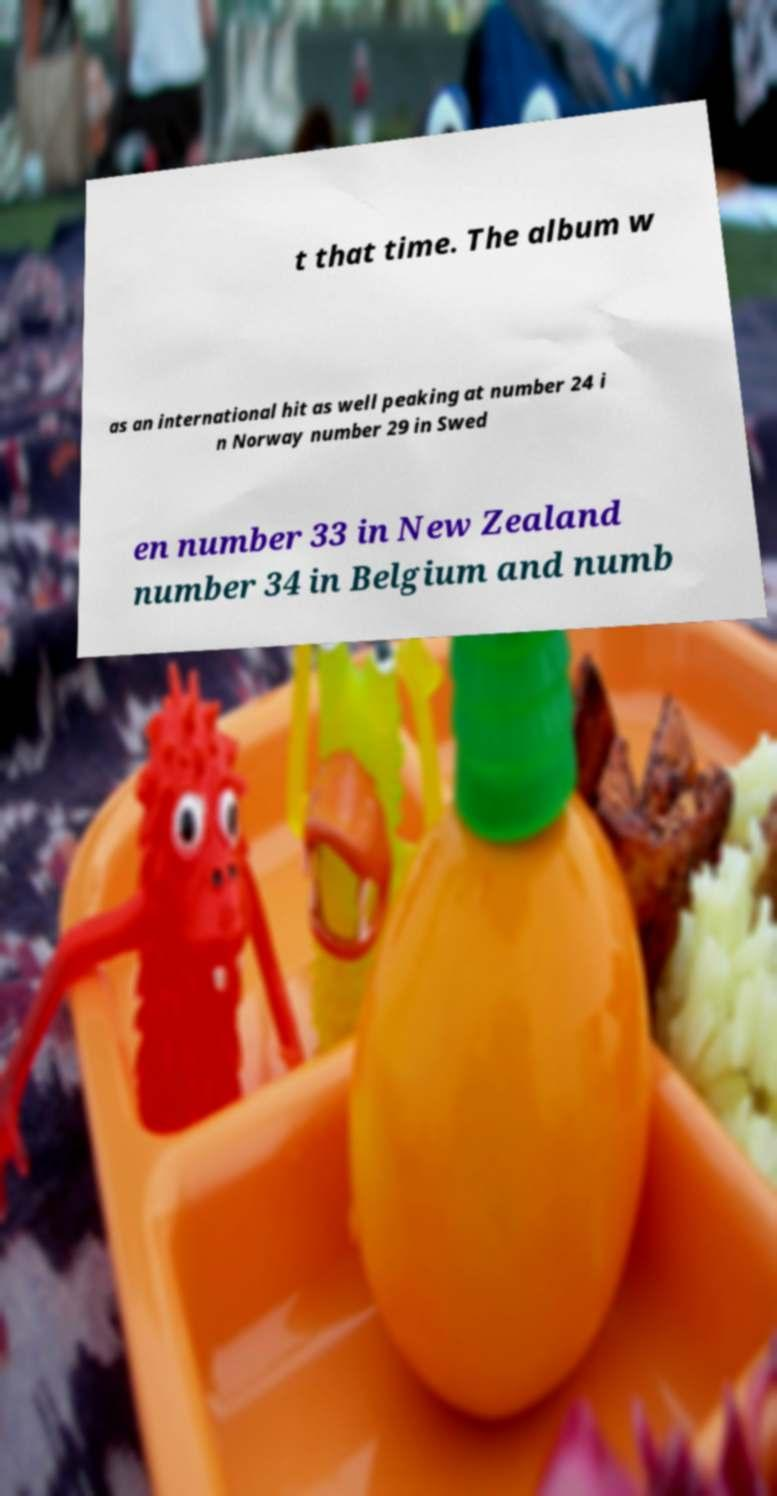Can you accurately transcribe the text from the provided image for me? t that time. The album w as an international hit as well peaking at number 24 i n Norway number 29 in Swed en number 33 in New Zealand number 34 in Belgium and numb 